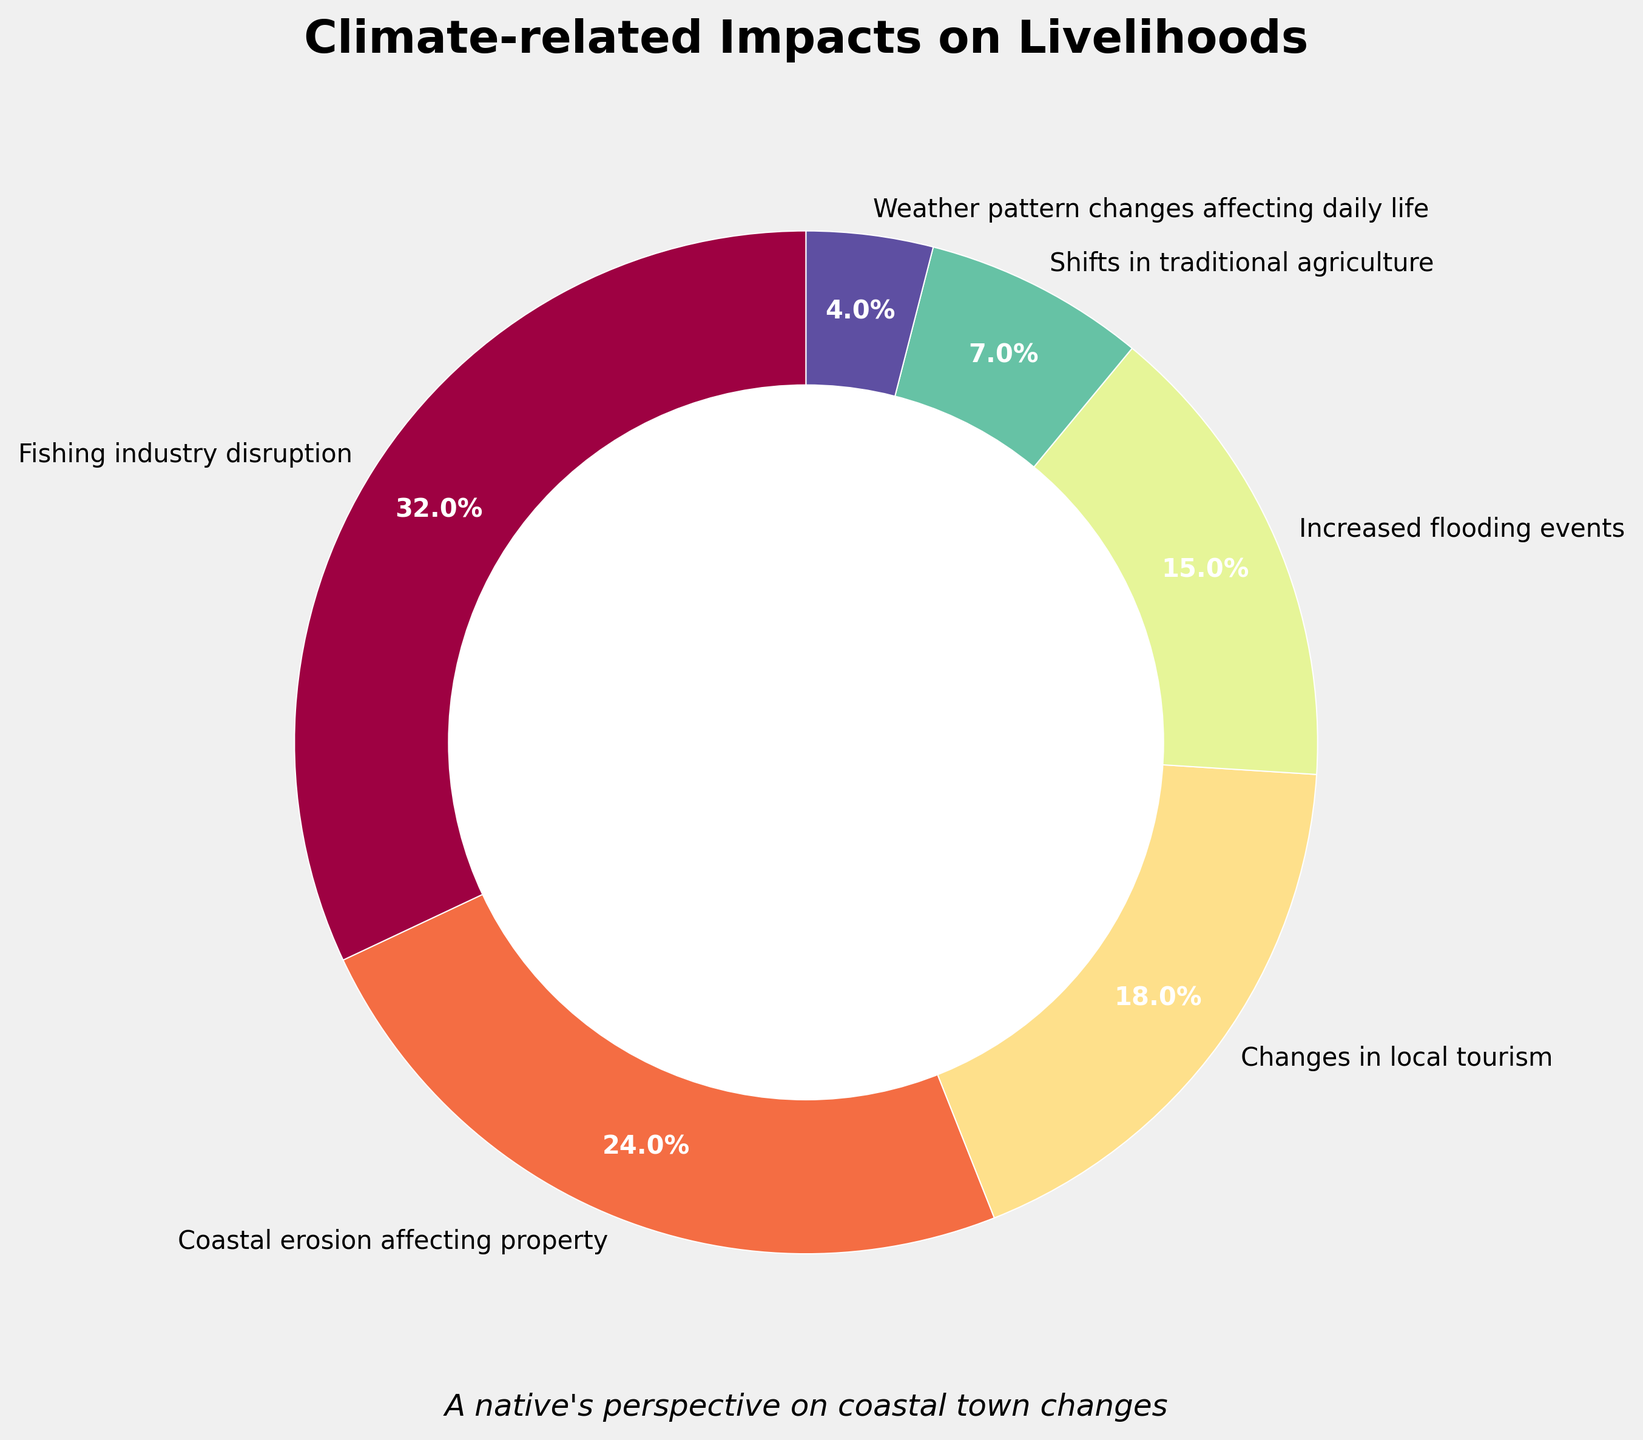Which impact has the highest proportion reported by residents? The largest segment in the pie chart is labeled "Fishing industry disruption," with the value showing 32%. Thus, "Fishing industry disruption" has the highest proportion.
Answer: Fishing industry disruption What is the combined percentage of residents reporting increased flooding events and shifts in traditional agriculture? To find the combined percentage, sum the percentages of "Increased flooding events" (15%) and "Shifts in traditional agriculture" (7%). 15% + 7% = 22%.
Answer: 22% Which impact has a higher proportion: Coastal erosion affecting property or Changes in local tourism? By comparing the two segments, "Coastal erosion affecting property" shows 24% and "Changes in local tourism" shows 18%. 24% > 18%, so "Coastal erosion affecting property" has a higher proportion.
Answer: Coastal erosion affecting property What percentage more do residents report fishing industry disruption compared to changes in local tourism? Subtract the percentage of "Changes in local tourism" (18%) from "Fishing industry disruption" (32%). 32% - 18% = 14%. Thus, 14% more residents report fishing industry disruption.
Answer: 14% Combine the percentage of residents reporting weather pattern changes affecting daily life and coastal erosion affecting property, then compare it to the percentage of residents reporting fishing industry disruption. Which is larger? Sum the percentages of "Weather pattern changes affecting daily life" (4%) and "Coastal erosion affecting property" (24%). The total is 4% + 24% = 28%. Compare this to "Fishing industry disruption" at 32%. 32% > 28%, so "Fishing industry disruption" is larger.
Answer: Fishing industry disruption Which impact is reported by the smallest proportion of residents? The smallest segment in the pie chart is labeled "Weather pattern changes affecting daily life," with the value showing 4%. Hence, "Weather pattern changes affecting daily life" is reported by the smallest proportion.
Answer: Weather pattern changes affecting daily life What is the percentage difference between the reports of coastal erosion affecting property and increased flooding events? Subtract the percentage of "Increased flooding events" (15%) from "Coastal erosion affecting property" (24%). 24% - 15% = 9%. Thus, the percentage difference is 9%.
Answer: 9% If we look at the impact labeled "Changes in local tourism," what color is used to represent it in the pie chart? The segment for "Changes in local tourism" could be identified by its corresponding color in the pie chart, which is colored based on the various hues in the Spectral colormap.
Answer: (answer based on color in the plot, e.g., orange, red, etc.) 